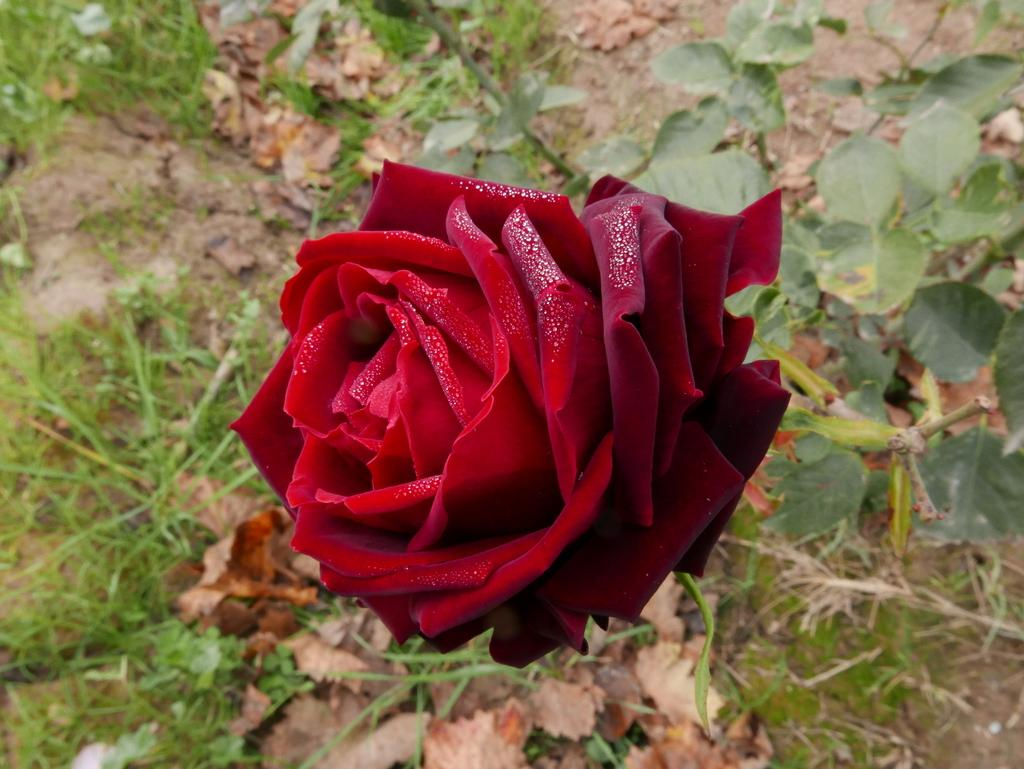What is the main subject of the image? There is a flower in the image. What color is the flower? The flower is red. What can be seen in the background of the image? There are plants in the background of the image. What color are the plants in the background? The plants in the background are green. What type of shock can be seen traveling through the cork in the image? There is no cork or shock present in the image; it features a red flower and green plants in the background. 